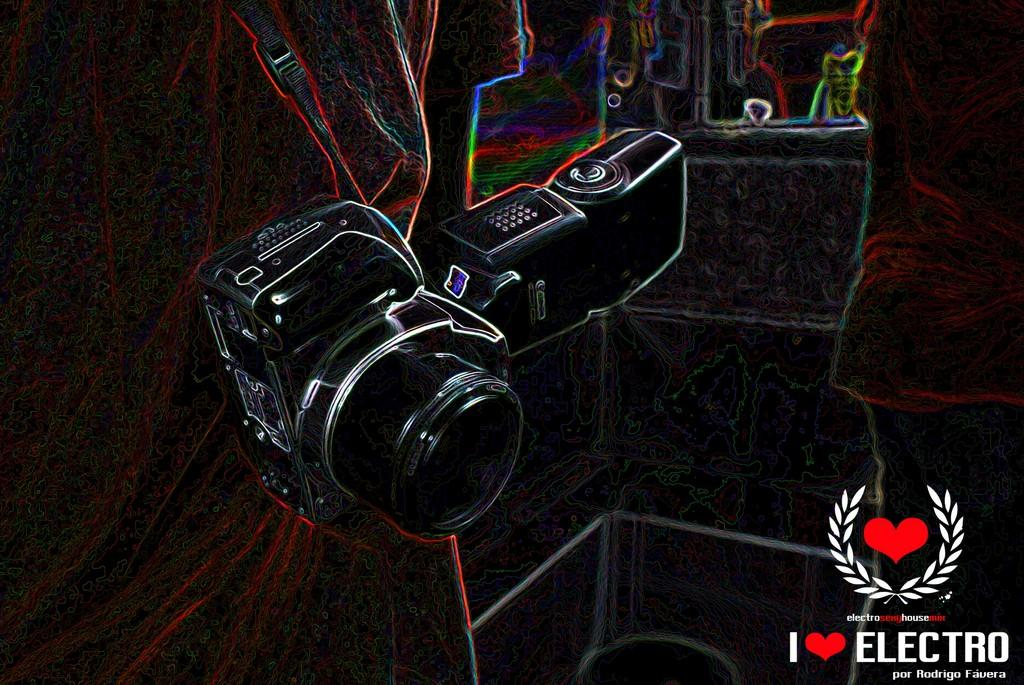What is the main subject of the image? There is a depiction of a camera in the image. Are there any additional features or elements in the image? Yes, there is a watermark in the image. How would you describe the overall appearance of the image? The image appears to be slightly dark. What type of beetle can be seen crawling on the camera in the image? There is no beetle present in the image; it only features a depiction of a camera and a watermark. 